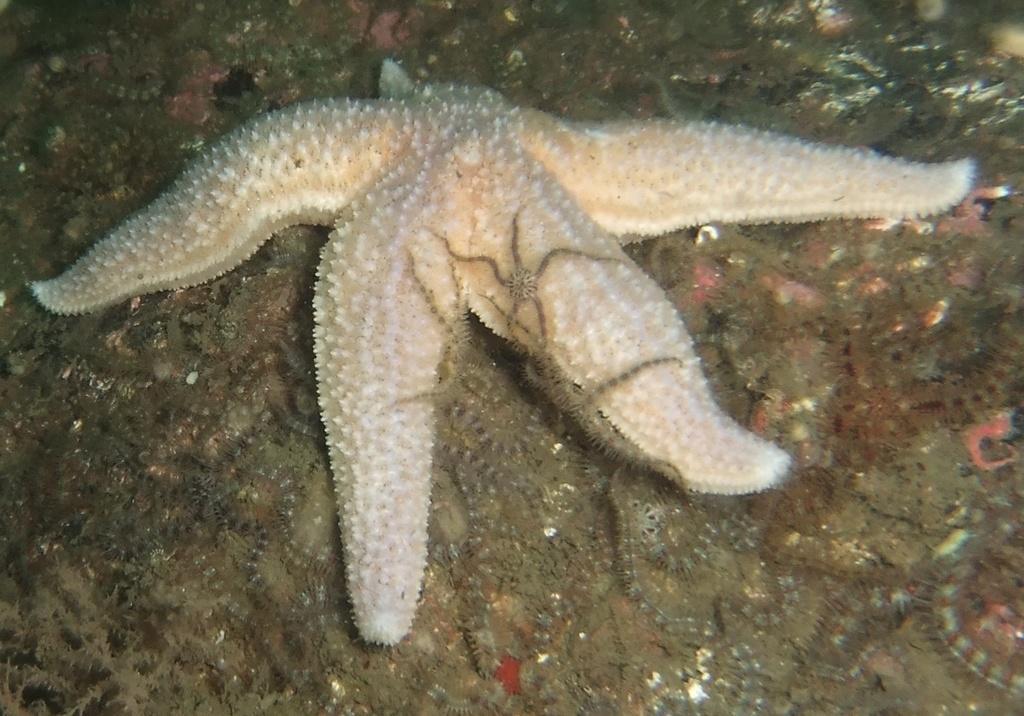Describe this image in one or two sentences. In the picture we can see a starfish and inside the water surface and near it, we can see some small starfishes. 